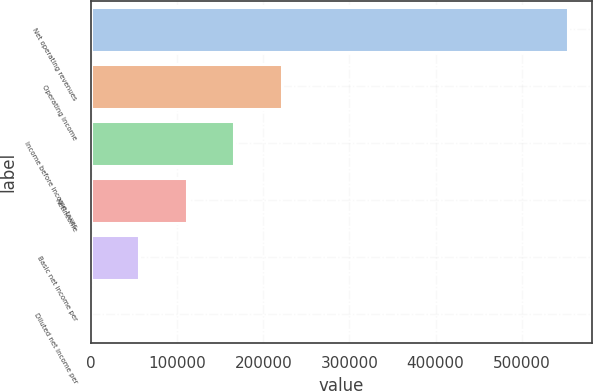<chart> <loc_0><loc_0><loc_500><loc_500><bar_chart><fcel>Net operating revenues<fcel>Operating income<fcel>Income before income taxes<fcel>Netincome<fcel>Basic net income per<fcel>Diluted net income per<nl><fcel>553446<fcel>221379<fcel>166034<fcel>110690<fcel>55345.4<fcel>0.92<nl></chart> 